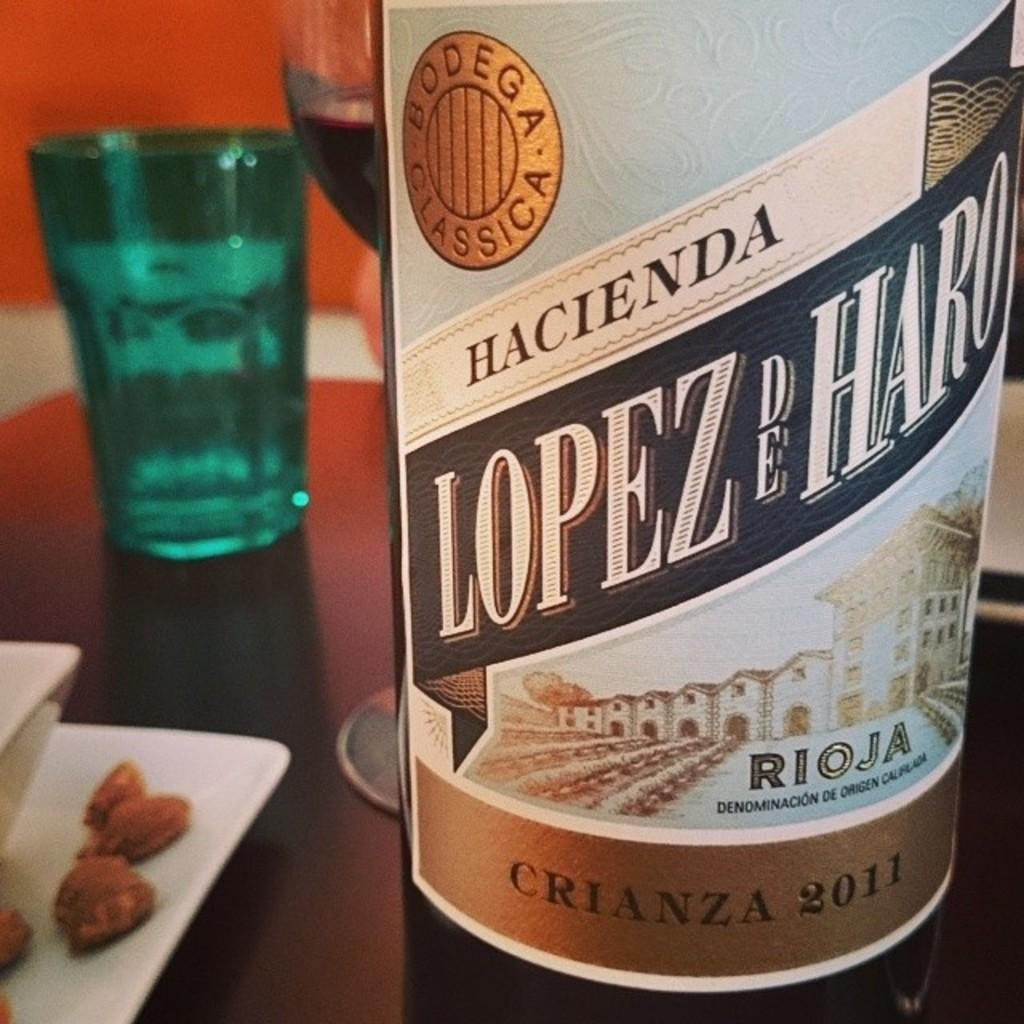Provide a one-sentence caption for the provided image. A bottle of Hacienda Lopez de Haro sits on a table. 